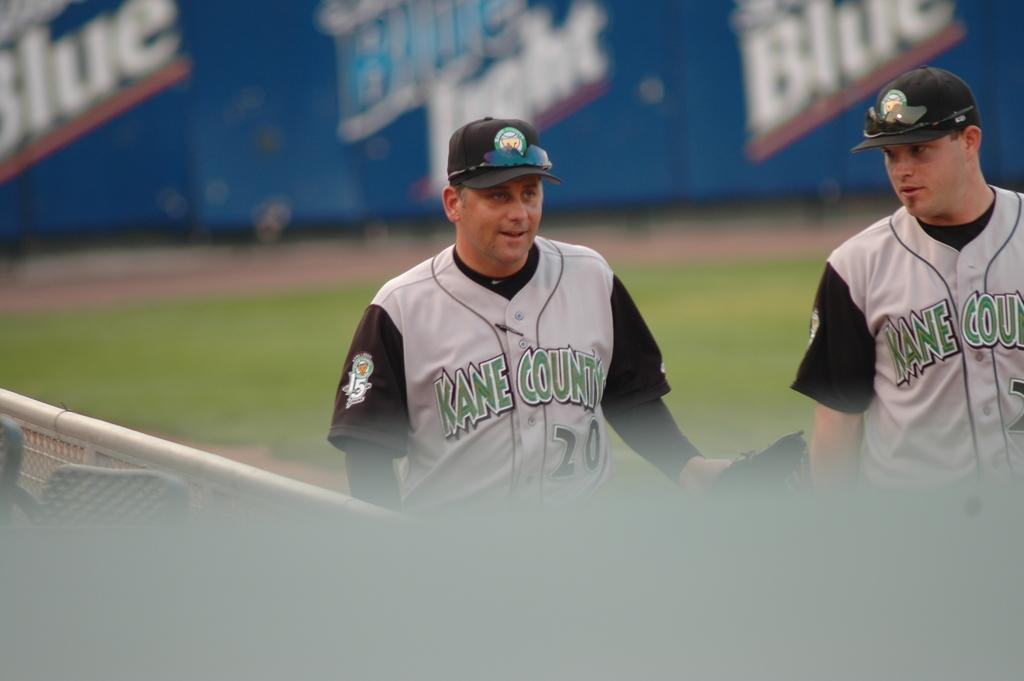<image>
Render a clear and concise summary of the photo. The two men are baseball players on the field with KANE COUNTY uniforms on. 